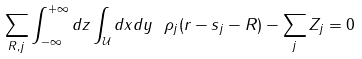<formula> <loc_0><loc_0><loc_500><loc_500>\sum _ { R , j } \int _ { - \infty } ^ { + \infty } d z \int _ { \mathcal { U } } d x d y \ \rho _ { j } ( r - s _ { j } - R ) - \sum _ { j } Z _ { j } = 0</formula> 